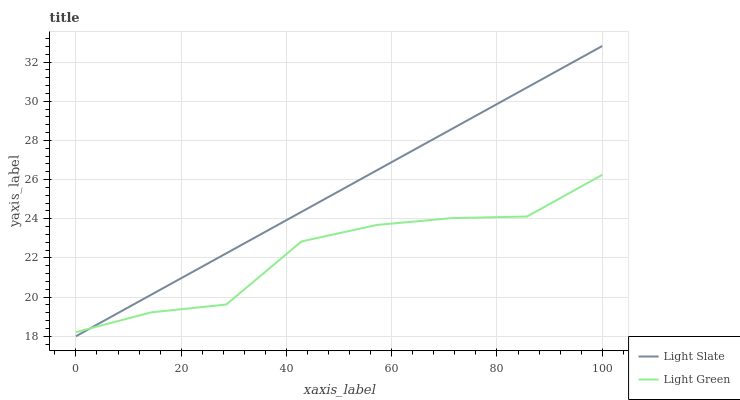Does Light Green have the minimum area under the curve?
Answer yes or no. Yes. Does Light Slate have the maximum area under the curve?
Answer yes or no. Yes. Does Light Green have the maximum area under the curve?
Answer yes or no. No. Is Light Slate the smoothest?
Answer yes or no. Yes. Is Light Green the roughest?
Answer yes or no. Yes. Is Light Green the smoothest?
Answer yes or no. No. Does Light Slate have the lowest value?
Answer yes or no. Yes. Does Light Green have the lowest value?
Answer yes or no. No. Does Light Slate have the highest value?
Answer yes or no. Yes. Does Light Green have the highest value?
Answer yes or no. No. Does Light Green intersect Light Slate?
Answer yes or no. Yes. Is Light Green less than Light Slate?
Answer yes or no. No. Is Light Green greater than Light Slate?
Answer yes or no. No. 